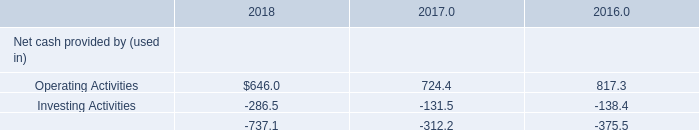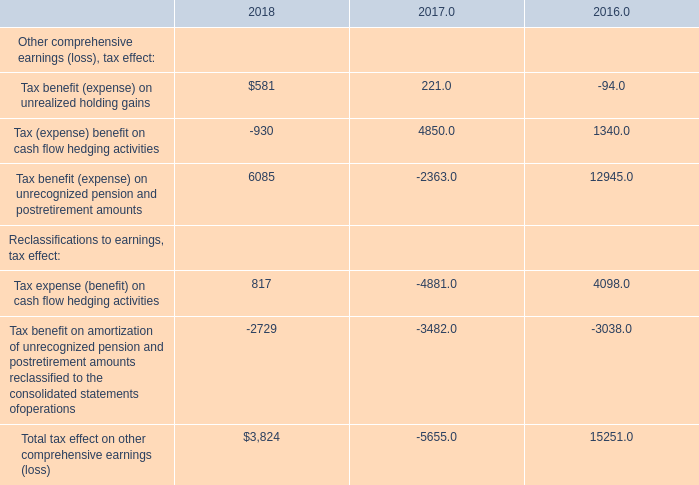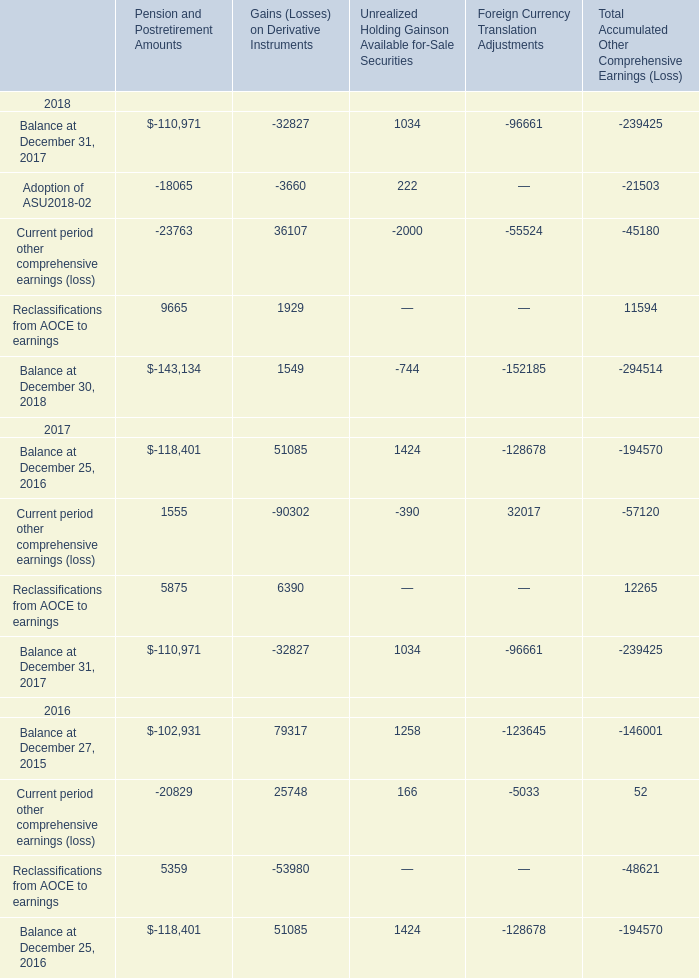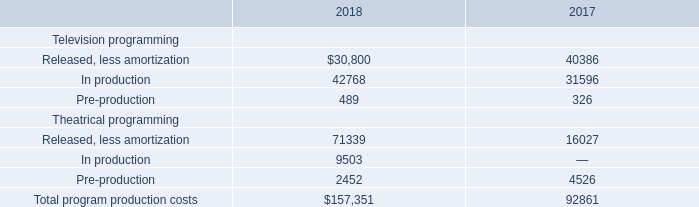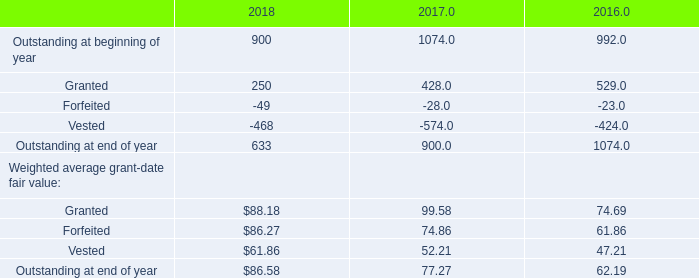What is the sum of the Total tax effect on other comprehensive earnings (loss) in the year where Tax benefit (expense) on unrealized holding gains is greater than 500? 
Answer: 3824. 